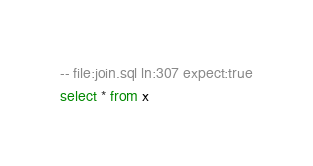Convert code to text. <code><loc_0><loc_0><loc_500><loc_500><_SQL_>-- file:join.sql ln:307 expect:true
select * from x
</code> 